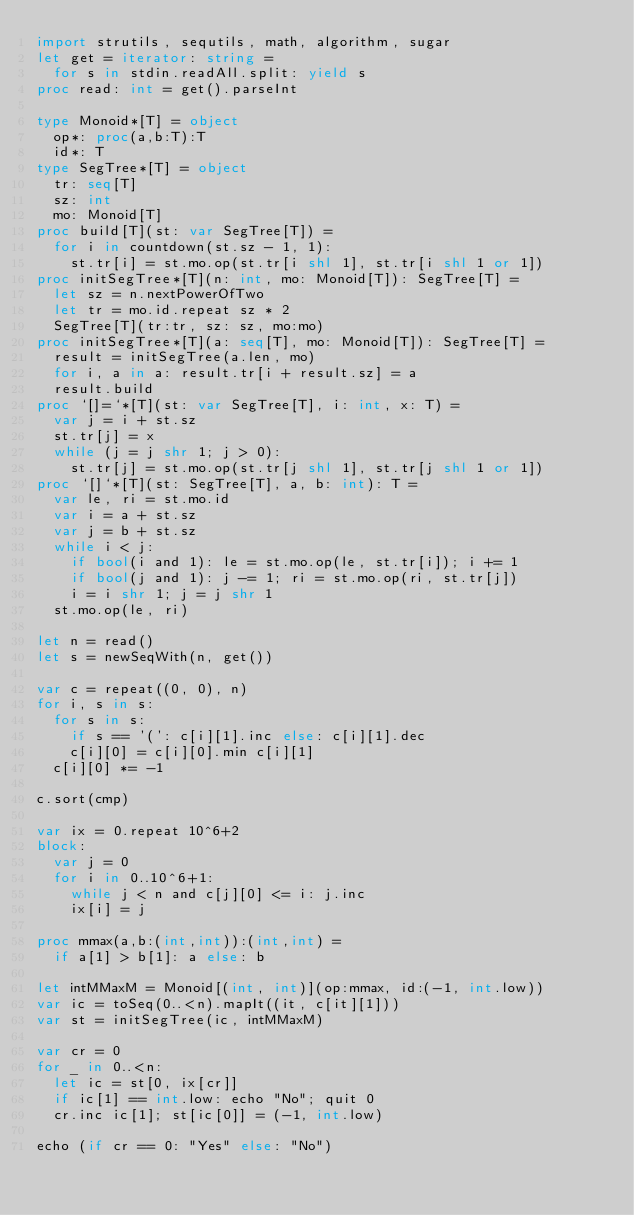Convert code to text. <code><loc_0><loc_0><loc_500><loc_500><_Nim_>import strutils, sequtils, math, algorithm, sugar
let get = iterator: string =
  for s in stdin.readAll.split: yield s
proc read: int = get().parseInt

type Monoid*[T] = object
  op*: proc(a,b:T):T
  id*: T
type SegTree*[T] = object
  tr: seq[T]
  sz: int
  mo: Monoid[T]
proc build[T](st: var SegTree[T]) =
  for i in countdown(st.sz - 1, 1):
    st.tr[i] = st.mo.op(st.tr[i shl 1], st.tr[i shl 1 or 1])
proc initSegTree*[T](n: int, mo: Monoid[T]): SegTree[T] =
  let sz = n.nextPowerOfTwo
  let tr = mo.id.repeat sz * 2
  SegTree[T](tr:tr, sz: sz, mo:mo)
proc initSegTree*[T](a: seq[T], mo: Monoid[T]): SegTree[T] = 
  result = initSegTree(a.len, mo)
  for i, a in a: result.tr[i + result.sz] = a
  result.build
proc `[]=`*[T](st: var SegTree[T], i: int, x: T) =
  var j = i + st.sz
  st.tr[j] = x
  while (j = j shr 1; j > 0):
    st.tr[j] = st.mo.op(st.tr[j shl 1], st.tr[j shl 1 or 1])
proc `[]`*[T](st: SegTree[T], a, b: int): T =
  var le, ri = st.mo.id
  var i = a + st.sz
  var j = b + st.sz
  while i < j:
    if bool(i and 1): le = st.mo.op(le, st.tr[i]); i += 1
    if bool(j and 1): j -= 1; ri = st.mo.op(ri, st.tr[j])
    i = i shr 1; j = j shr 1
  st.mo.op(le, ri)

let n = read()
let s = newSeqWith(n, get())

var c = repeat((0, 0), n)
for i, s in s:
  for s in s:
    if s == '(': c[i][1].inc else: c[i][1].dec
    c[i][0] = c[i][0].min c[i][1]
  c[i][0] *= -1

c.sort(cmp)

var ix = 0.repeat 10^6+2
block:
  var j = 0
  for i in 0..10^6+1:
    while j < n and c[j][0] <= i: j.inc
    ix[i] = j

proc mmax(a,b:(int,int)):(int,int) =
  if a[1] > b[1]: a else: b

let intMMaxM = Monoid[(int, int)](op:mmax, id:(-1, int.low))
var ic = toSeq(0..<n).mapIt((it, c[it][1]))
var st = initSegTree(ic, intMMaxM)

var cr = 0
for _ in 0..<n:
  let ic = st[0, ix[cr]]
  if ic[1] == int.low: echo "No"; quit 0
  cr.inc ic[1]; st[ic[0]] = (-1, int.low)

echo (if cr == 0: "Yes" else: "No")</code> 